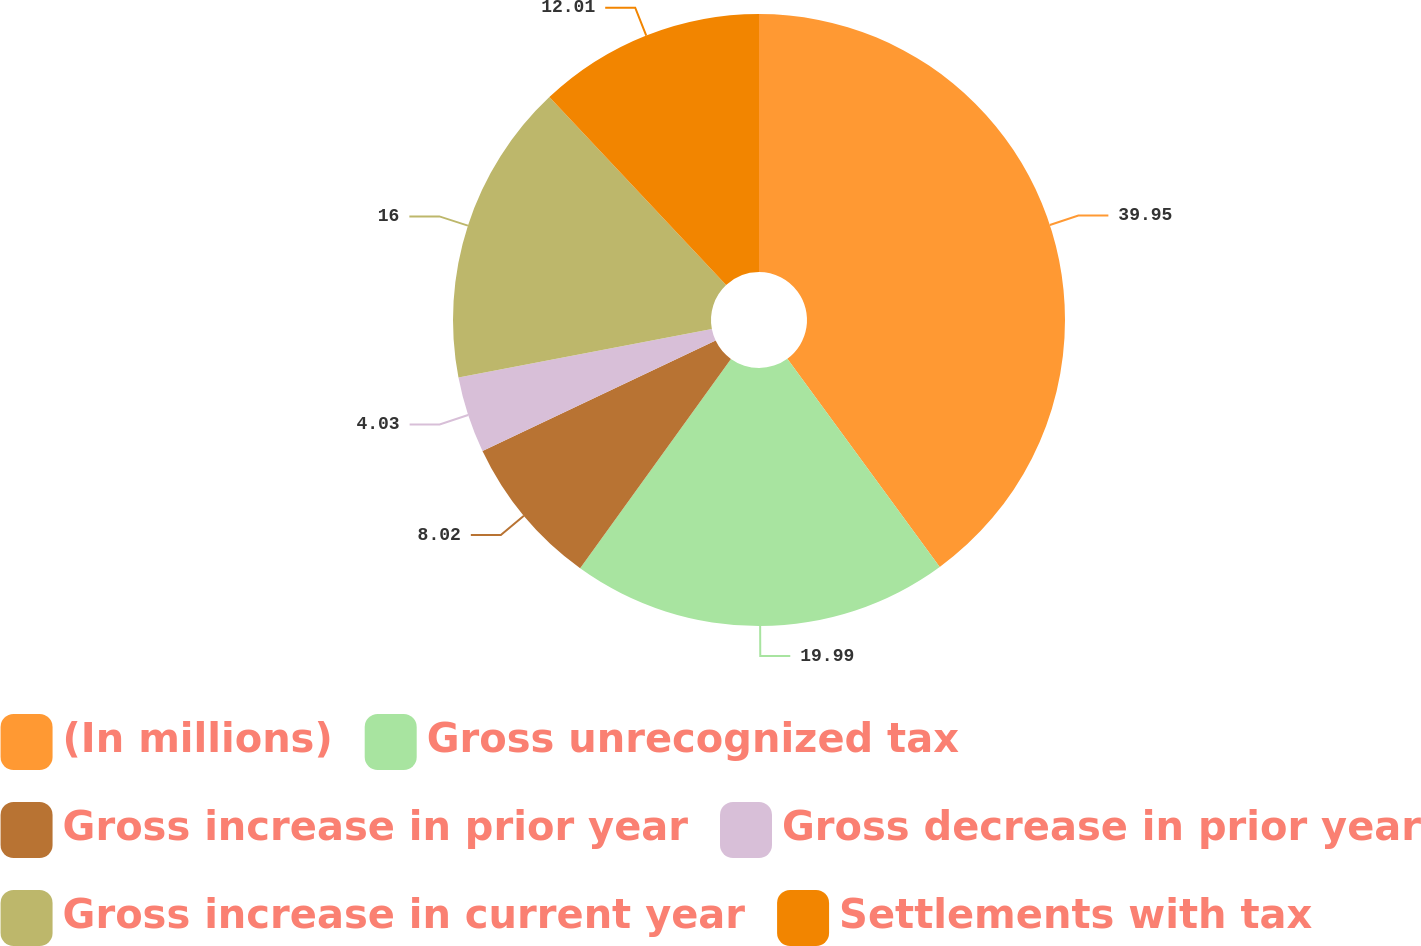Convert chart to OTSL. <chart><loc_0><loc_0><loc_500><loc_500><pie_chart><fcel>(In millions)<fcel>Gross unrecognized tax<fcel>Gross increase in prior year<fcel>Gross decrease in prior year<fcel>Gross increase in current year<fcel>Settlements with tax<nl><fcel>39.94%<fcel>19.99%<fcel>8.02%<fcel>4.03%<fcel>16.0%<fcel>12.01%<nl></chart> 